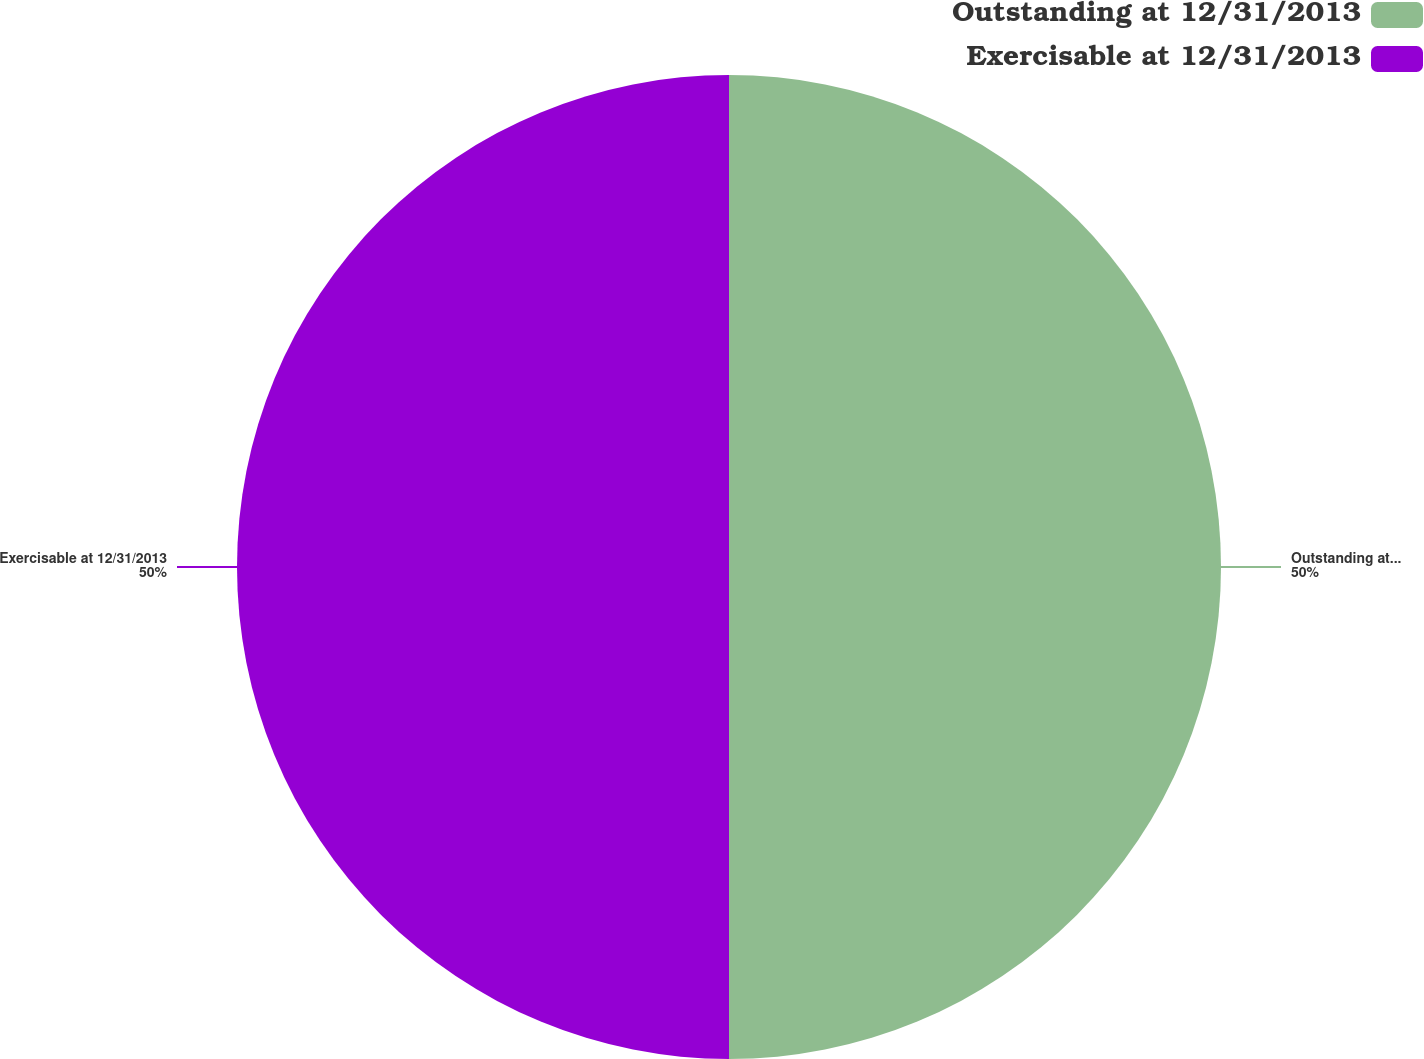<chart> <loc_0><loc_0><loc_500><loc_500><pie_chart><fcel>Outstanding at 12/31/2013<fcel>Exercisable at 12/31/2013<nl><fcel>50.0%<fcel>50.0%<nl></chart> 